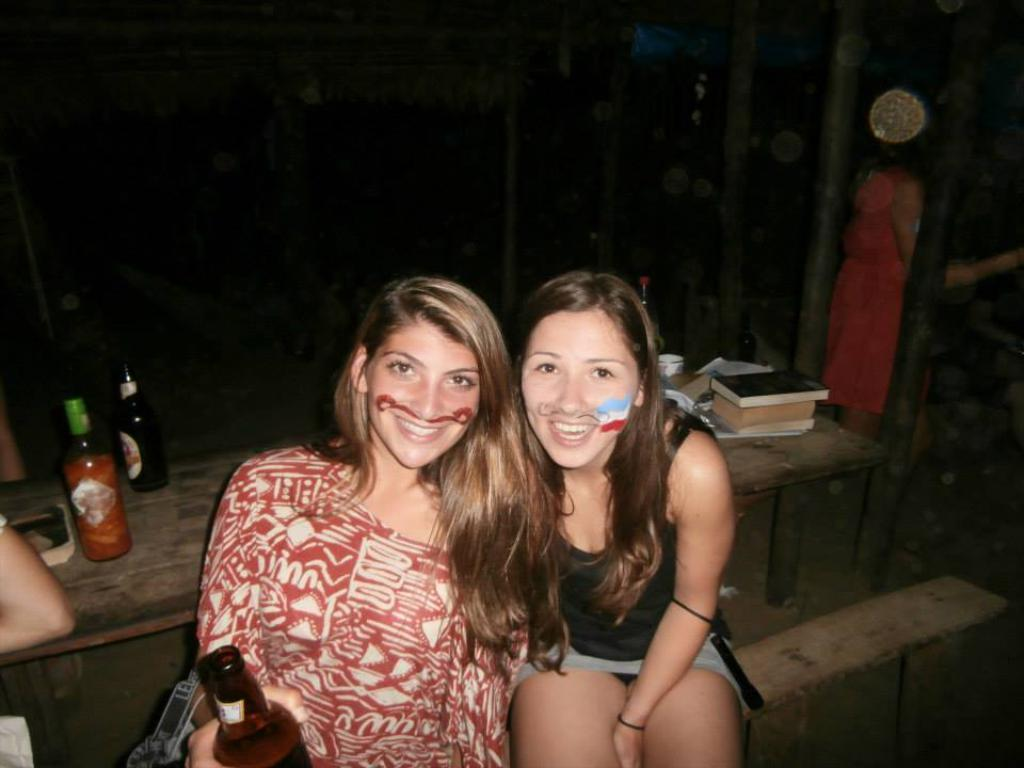How many people are sitting in the image? There are two women sitting in the image. What objects can be seen near the women? There are bottles and books in the image. What type of pickle is being used as a prop in the scene? There is no pickle present in the image. What experience can be gained from observing the women in the image? The image does not convey any specific experience; it simply shows two women sitting with bottles and books nearby. 